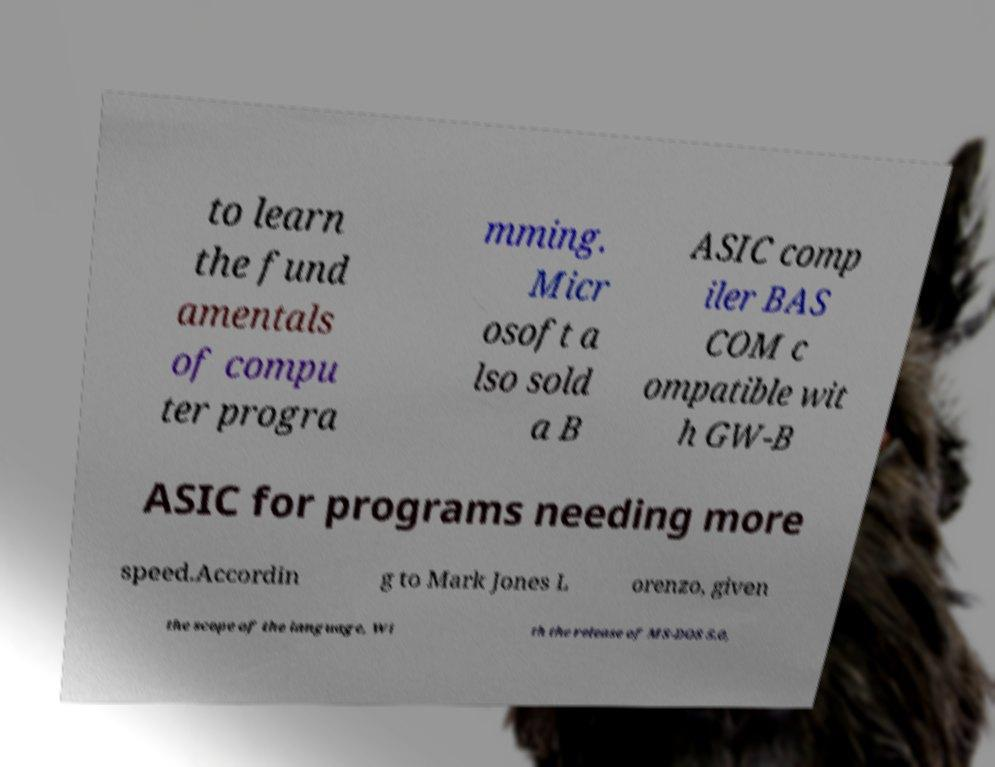Could you assist in decoding the text presented in this image and type it out clearly? to learn the fund amentals of compu ter progra mming. Micr osoft a lso sold a B ASIC comp iler BAS COM c ompatible wit h GW-B ASIC for programs needing more speed.Accordin g to Mark Jones L orenzo, given the scope of the language, Wi th the release of MS-DOS 5.0, 